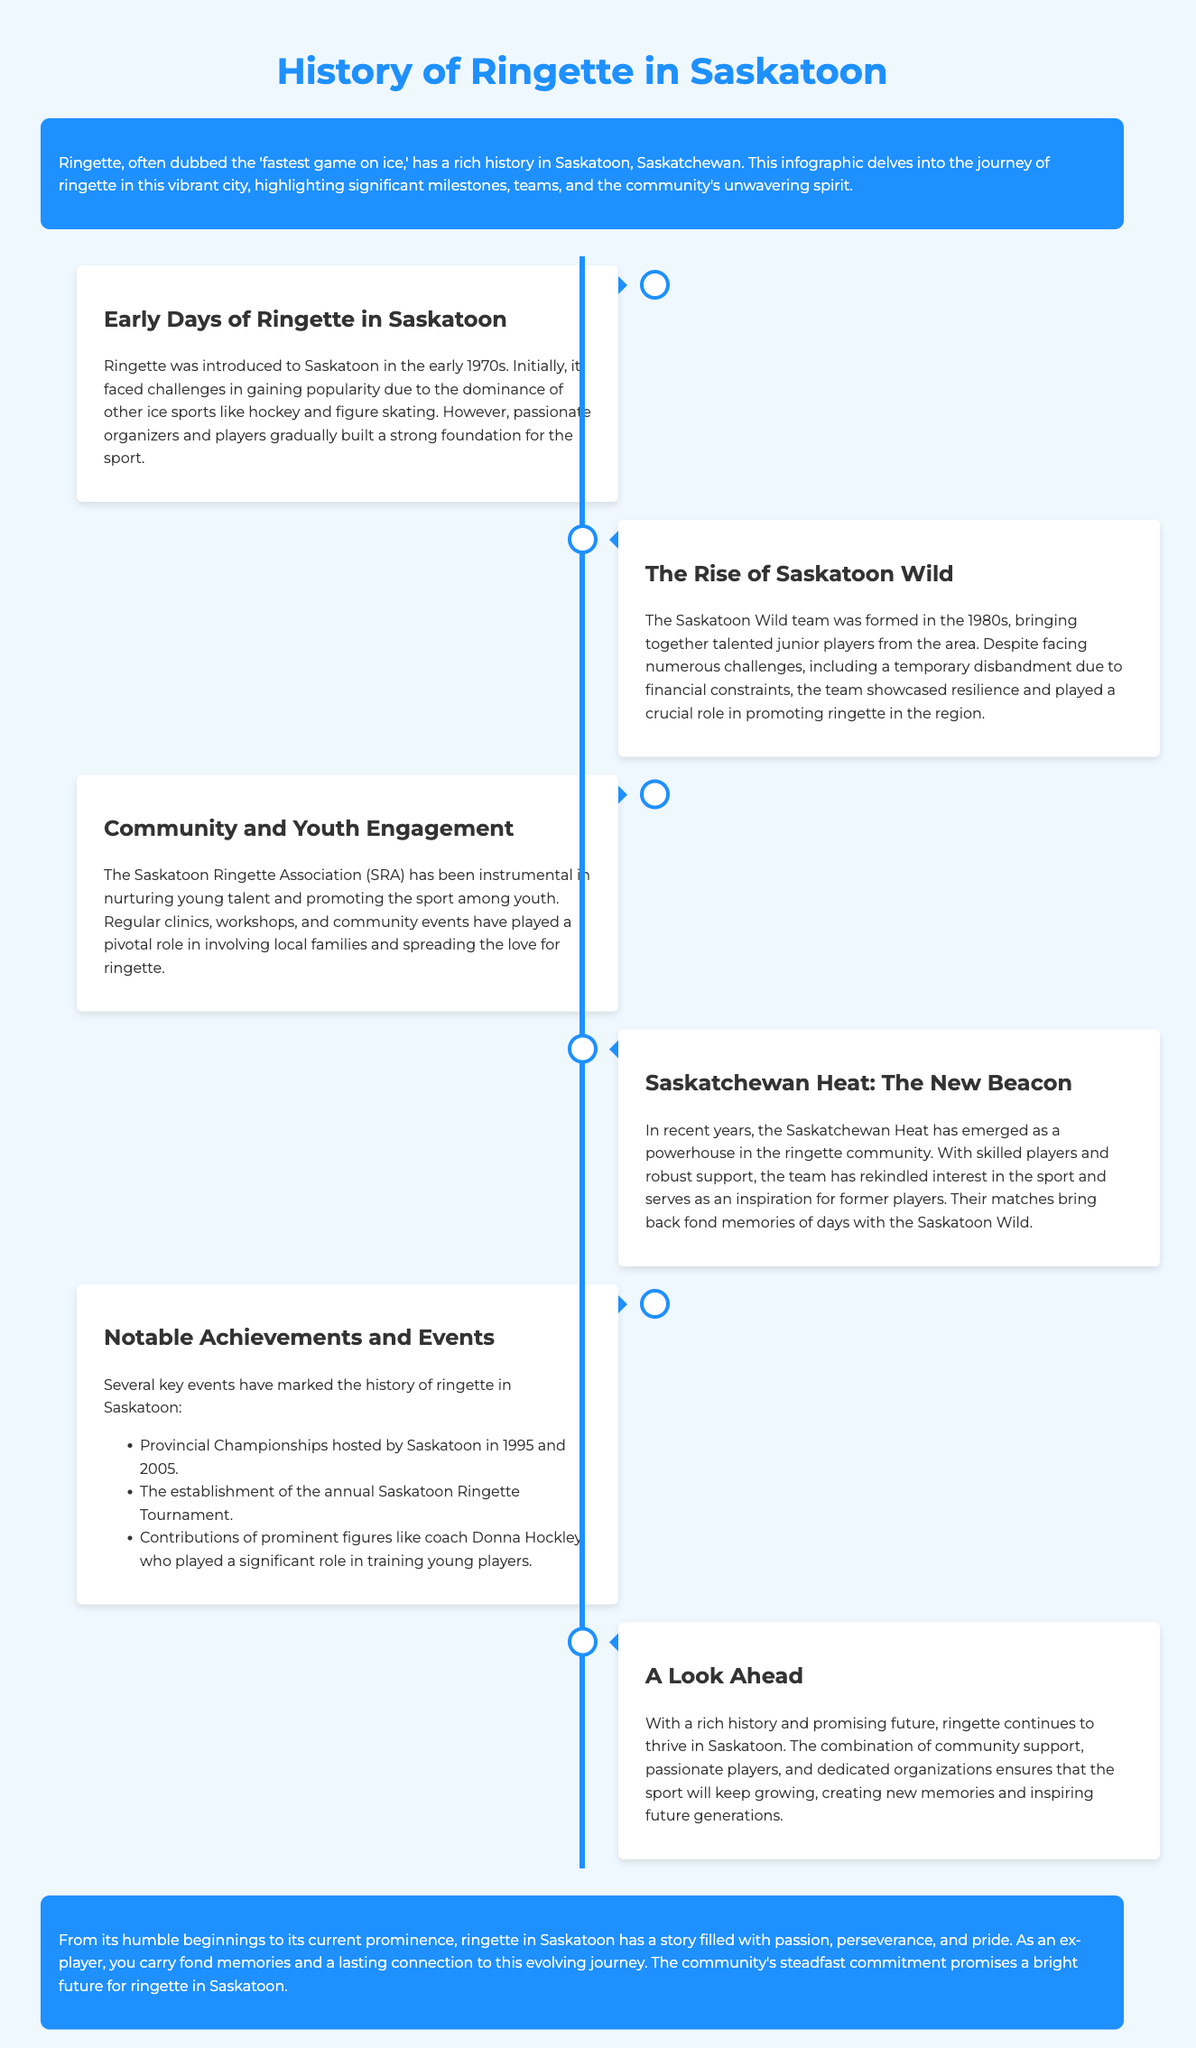What decade was ringette introduced to Saskatoon? The document states that ringette was introduced to Saskatoon in the early 1970s.
Answer: 1970s What was the name of the team formed in the 1980s? The team formed in the 1980s was called the Saskatoon Wild.
Answer: Saskatoon Wild What organization has been pivotal in promoting youth engagement in ringette? The Saskatoon Ringette Association (SRA) has played a crucial role in promoting the sport among youth.
Answer: Saskatoon Ringette Association (SRA) In which years did Saskatoon host the Provincial Championships? According to the document, Saskatoon hosted the Provincial Championships in 1995 and 2005.
Answer: 1995 and 2005 What is the name of the current ringette team mentioned in the document? The current team mentioned is the Saskatchewan Heat.
Answer: Saskatchewan Heat What significant role did coach Donna Hockley play? The document highlights Donna Hockley's contributions in training young players.
Answer: Training young players What milestone has rekindled interest in ringette according to the document? The emergence of the Saskatchewan Heat has rekindled interest in the sport.
Answer: Saskatchewan Heat Why is the timeline structure effective for this infographic? The timeline structure effectively showcases the chronological history of ringette in Saskatoon, allowing for easy tracking of events.
Answer: Chronological history What does the conclusion of the infographic emphasize about the future of ringette? The conclusion emphasizes that community support and passionate players will ensure the continued growth of ringette.
Answer: Continued growth 